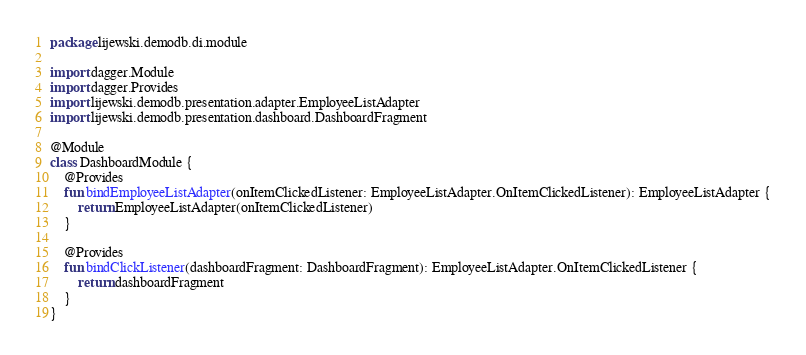<code> <loc_0><loc_0><loc_500><loc_500><_Kotlin_>package lijewski.demodb.di.module

import dagger.Module
import dagger.Provides
import lijewski.demodb.presentation.adapter.EmployeeListAdapter
import lijewski.demodb.presentation.dashboard.DashboardFragment

@Module
class DashboardModule {
    @Provides
    fun bindEmployeeListAdapter(onItemClickedListener: EmployeeListAdapter.OnItemClickedListener): EmployeeListAdapter {
        return EmployeeListAdapter(onItemClickedListener)
    }

    @Provides
    fun bindClickListener(dashboardFragment: DashboardFragment): EmployeeListAdapter.OnItemClickedListener {
        return dashboardFragment
    }
}
</code> 